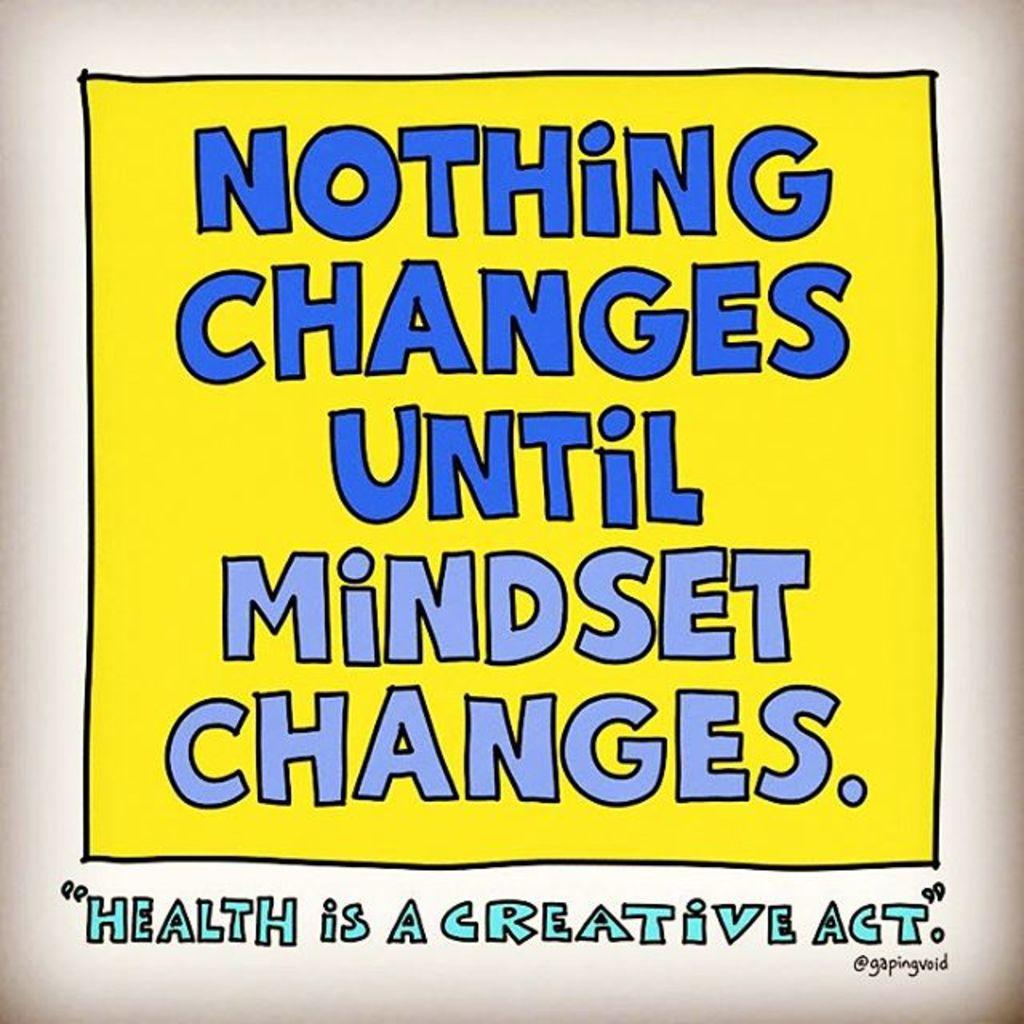<image>
Give a short and clear explanation of the subsequent image. In blue writing, a poster has an inspirational phrase that concludes Health is a creative act. 